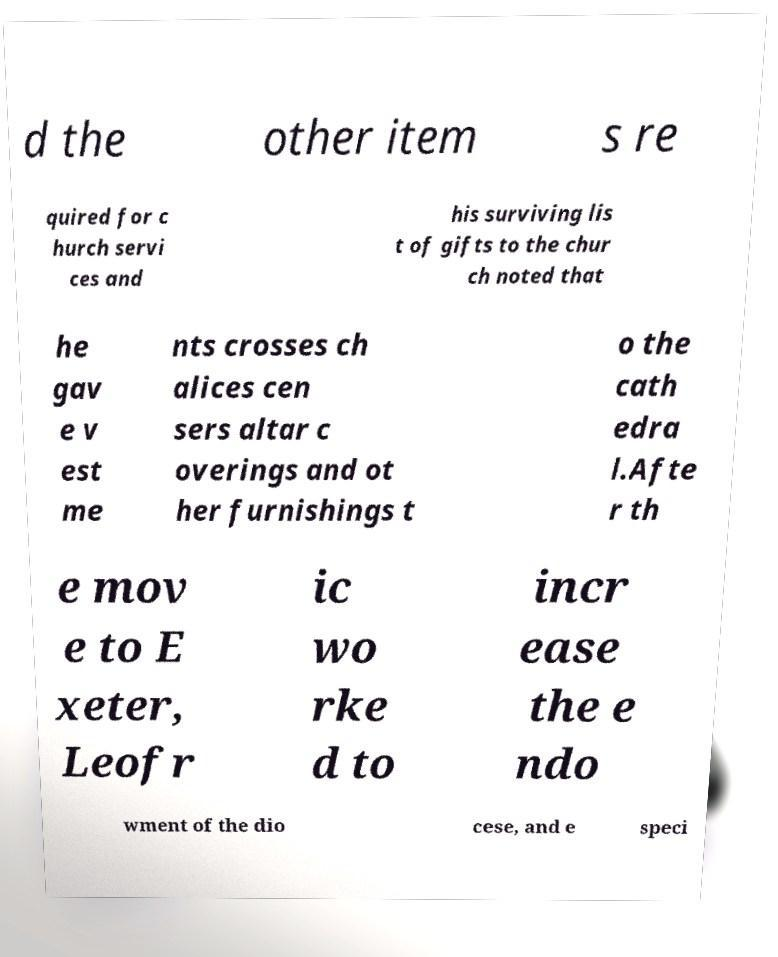Please read and relay the text visible in this image. What does it say? d the other item s re quired for c hurch servi ces and his surviving lis t of gifts to the chur ch noted that he gav e v est me nts crosses ch alices cen sers altar c overings and ot her furnishings t o the cath edra l.Afte r th e mov e to E xeter, Leofr ic wo rke d to incr ease the e ndo wment of the dio cese, and e speci 